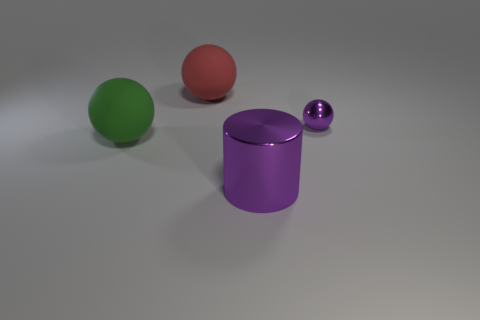Subtract all purple balls. How many balls are left? 2 Subtract all red spheres. How many spheres are left? 2 Add 1 red balls. How many objects exist? 5 Subtract 2 spheres. How many spheres are left? 1 Subtract 0 red blocks. How many objects are left? 4 Subtract all cylinders. How many objects are left? 3 Subtract all yellow balls. Subtract all brown blocks. How many balls are left? 3 Subtract all blue cylinders. Subtract all purple metallic things. How many objects are left? 2 Add 3 purple spheres. How many purple spheres are left? 4 Add 3 tiny purple balls. How many tiny purple balls exist? 4 